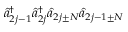<formula> <loc_0><loc_0><loc_500><loc_500>\hat { a } _ { 2 j - 1 } ^ { \dagger } \hat { a } _ { 2 j } ^ { \dagger } \hat { a } _ { 2 j \pm N } \hat { a } _ { 2 j - 1 \pm N }</formula> 